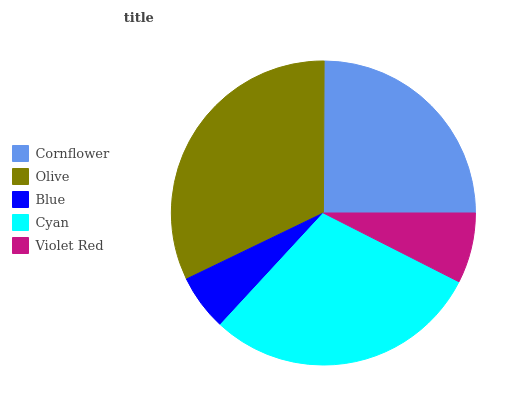Is Blue the minimum?
Answer yes or no. Yes. Is Olive the maximum?
Answer yes or no. Yes. Is Olive the minimum?
Answer yes or no. No. Is Blue the maximum?
Answer yes or no. No. Is Olive greater than Blue?
Answer yes or no. Yes. Is Blue less than Olive?
Answer yes or no. Yes. Is Blue greater than Olive?
Answer yes or no. No. Is Olive less than Blue?
Answer yes or no. No. Is Cornflower the high median?
Answer yes or no. Yes. Is Cornflower the low median?
Answer yes or no. Yes. Is Violet Red the high median?
Answer yes or no. No. Is Blue the low median?
Answer yes or no. No. 